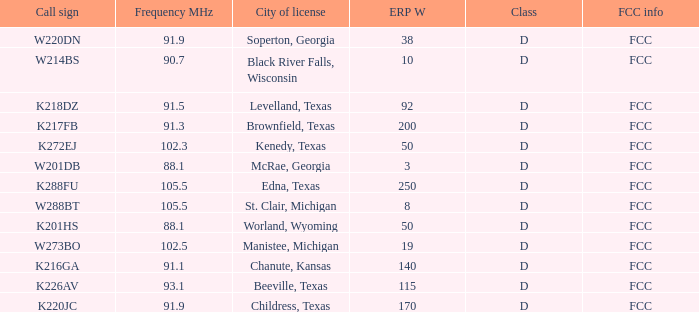What is Call Sign, when ERP W is greater than 50? K216GA, K226AV, K217FB, K220JC, K288FU, K218DZ. 